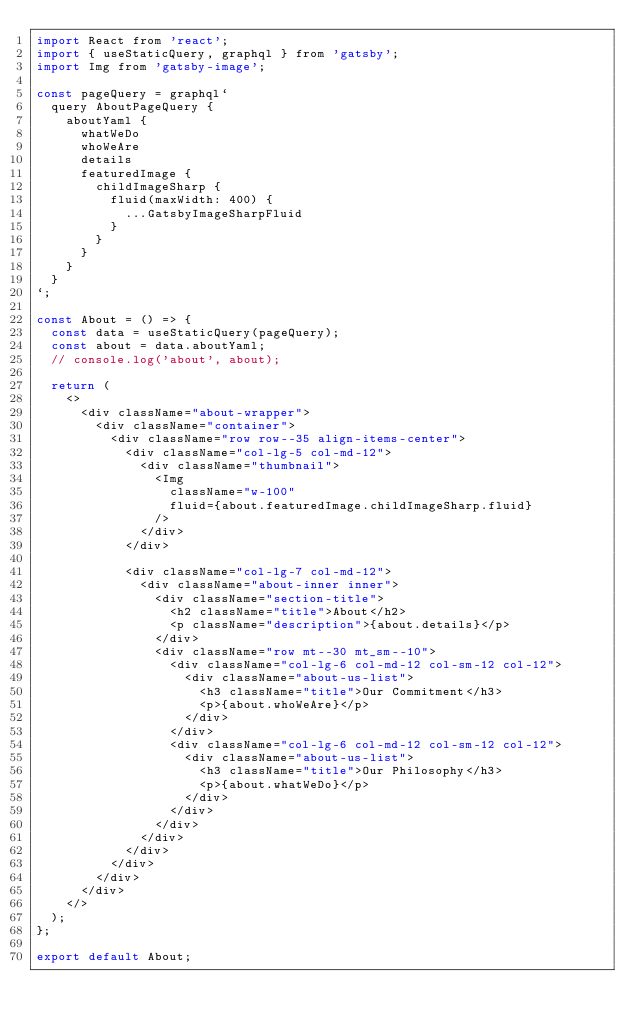Convert code to text. <code><loc_0><loc_0><loc_500><loc_500><_JavaScript_>import React from 'react';
import { useStaticQuery, graphql } from 'gatsby';
import Img from 'gatsby-image';

const pageQuery = graphql`
  query AboutPageQuery {
    aboutYaml {
      whatWeDo
      whoWeAre
      details
      featuredImage {
        childImageSharp {
          fluid(maxWidth: 400) {
            ...GatsbyImageSharpFluid
          }
        }
      }
    }
  }
`;

const About = () => {
  const data = useStaticQuery(pageQuery);
  const about = data.aboutYaml;
  // console.log('about', about);

  return (
    <>
      <div className="about-wrapper">
        <div className="container">
          <div className="row row--35 align-items-center">
            <div className="col-lg-5 col-md-12">
              <div className="thumbnail">
                <Img
                  className="w-100"
                  fluid={about.featuredImage.childImageSharp.fluid}
                />
              </div>
            </div>

            <div className="col-lg-7 col-md-12">
              <div className="about-inner inner">
                <div className="section-title">
                  <h2 className="title">About</h2>
                  <p className="description">{about.details}</p>
                </div>
                <div className="row mt--30 mt_sm--10">
                  <div className="col-lg-6 col-md-12 col-sm-12 col-12">
                    <div className="about-us-list">
                      <h3 className="title">Our Commitment</h3>
                      <p>{about.whoWeAre}</p>
                    </div>
                  </div>
                  <div className="col-lg-6 col-md-12 col-sm-12 col-12">
                    <div className="about-us-list">
                      <h3 className="title">Our Philosophy</h3>
                      <p>{about.whatWeDo}</p>
                    </div>
                  </div>
                </div>
              </div>
            </div>
          </div>
        </div>
      </div>
    </>
  );
};

export default About;
</code> 